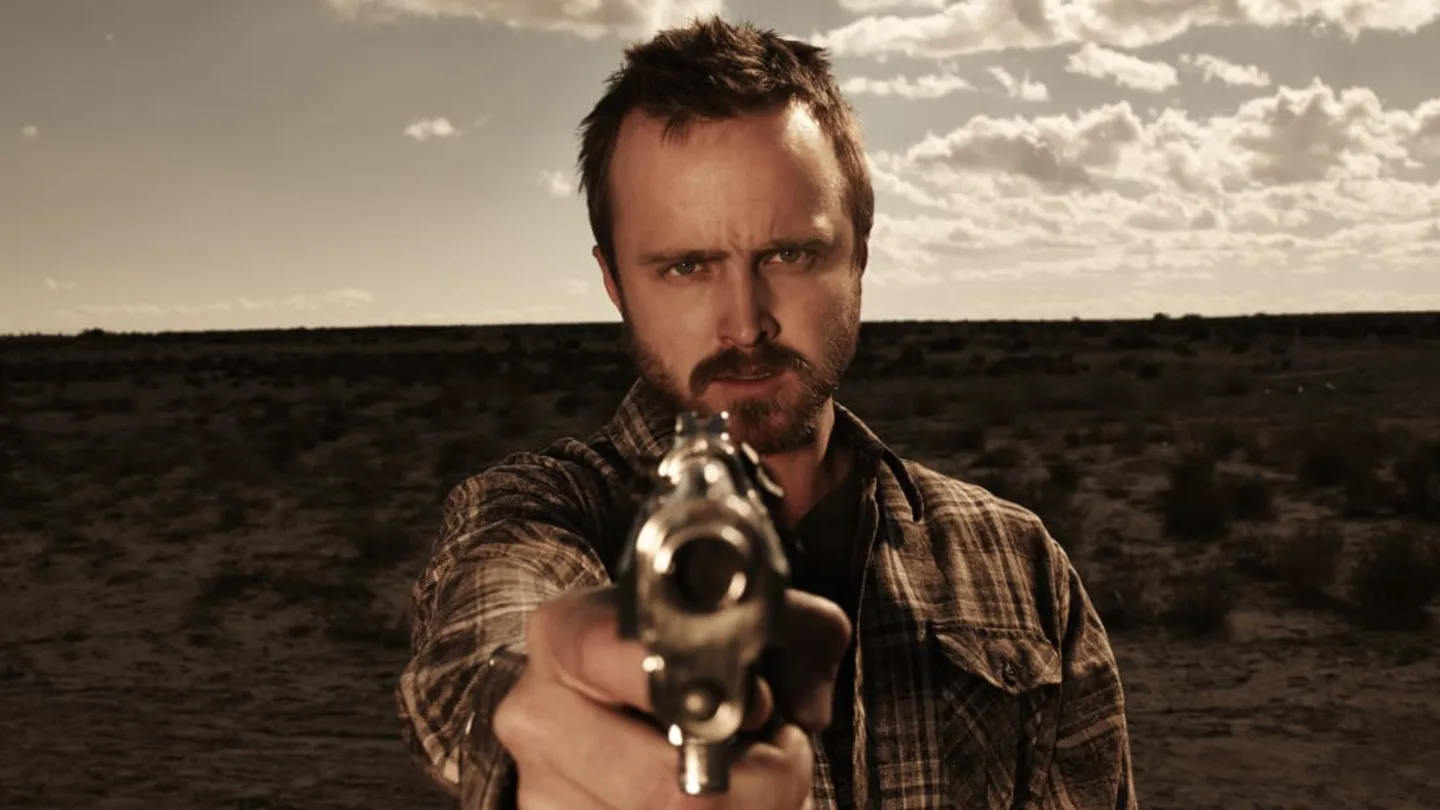Write a detailed description of the given image. The image features a man with a focused and intense expression, standing in a desert landscape under a cloudy sky. He wears a black and white plaid shirt and points a revolver directly at the camera. The desert setting is vast and barren, adding a dramatic effect to the scene. The image is color-treated to have a sepia tone, contributing to its gritty aesthetic. 